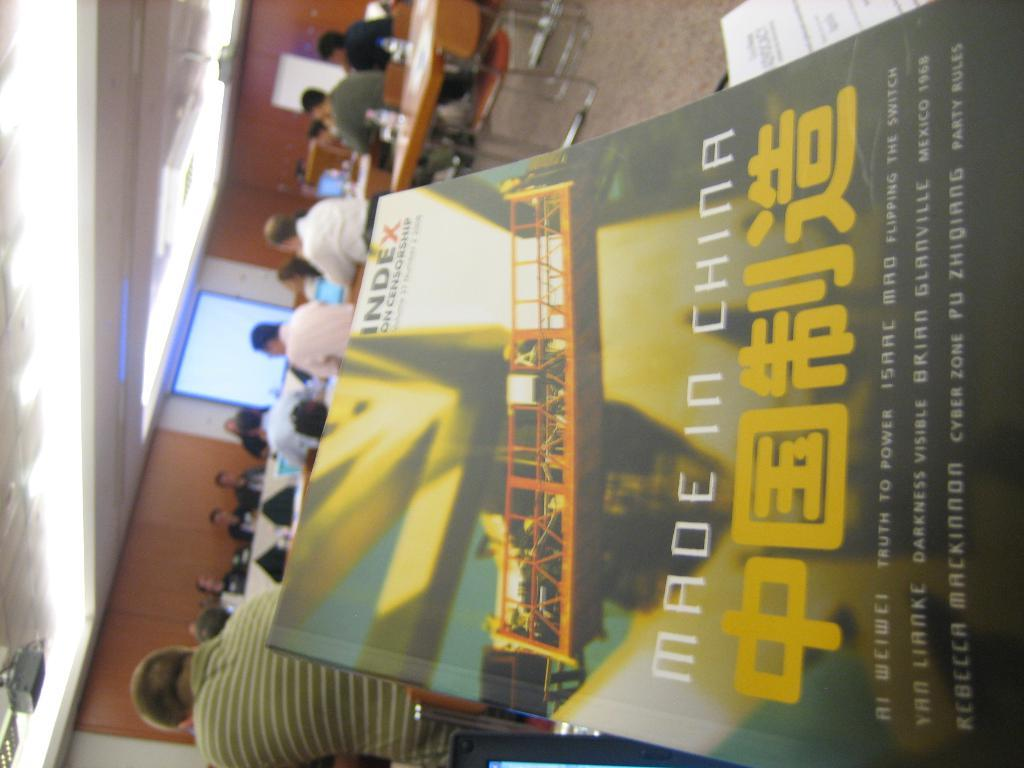<image>
Give a short and clear explanation of the subsequent image. A book titled "Made in China" with a index logo on the top right. 